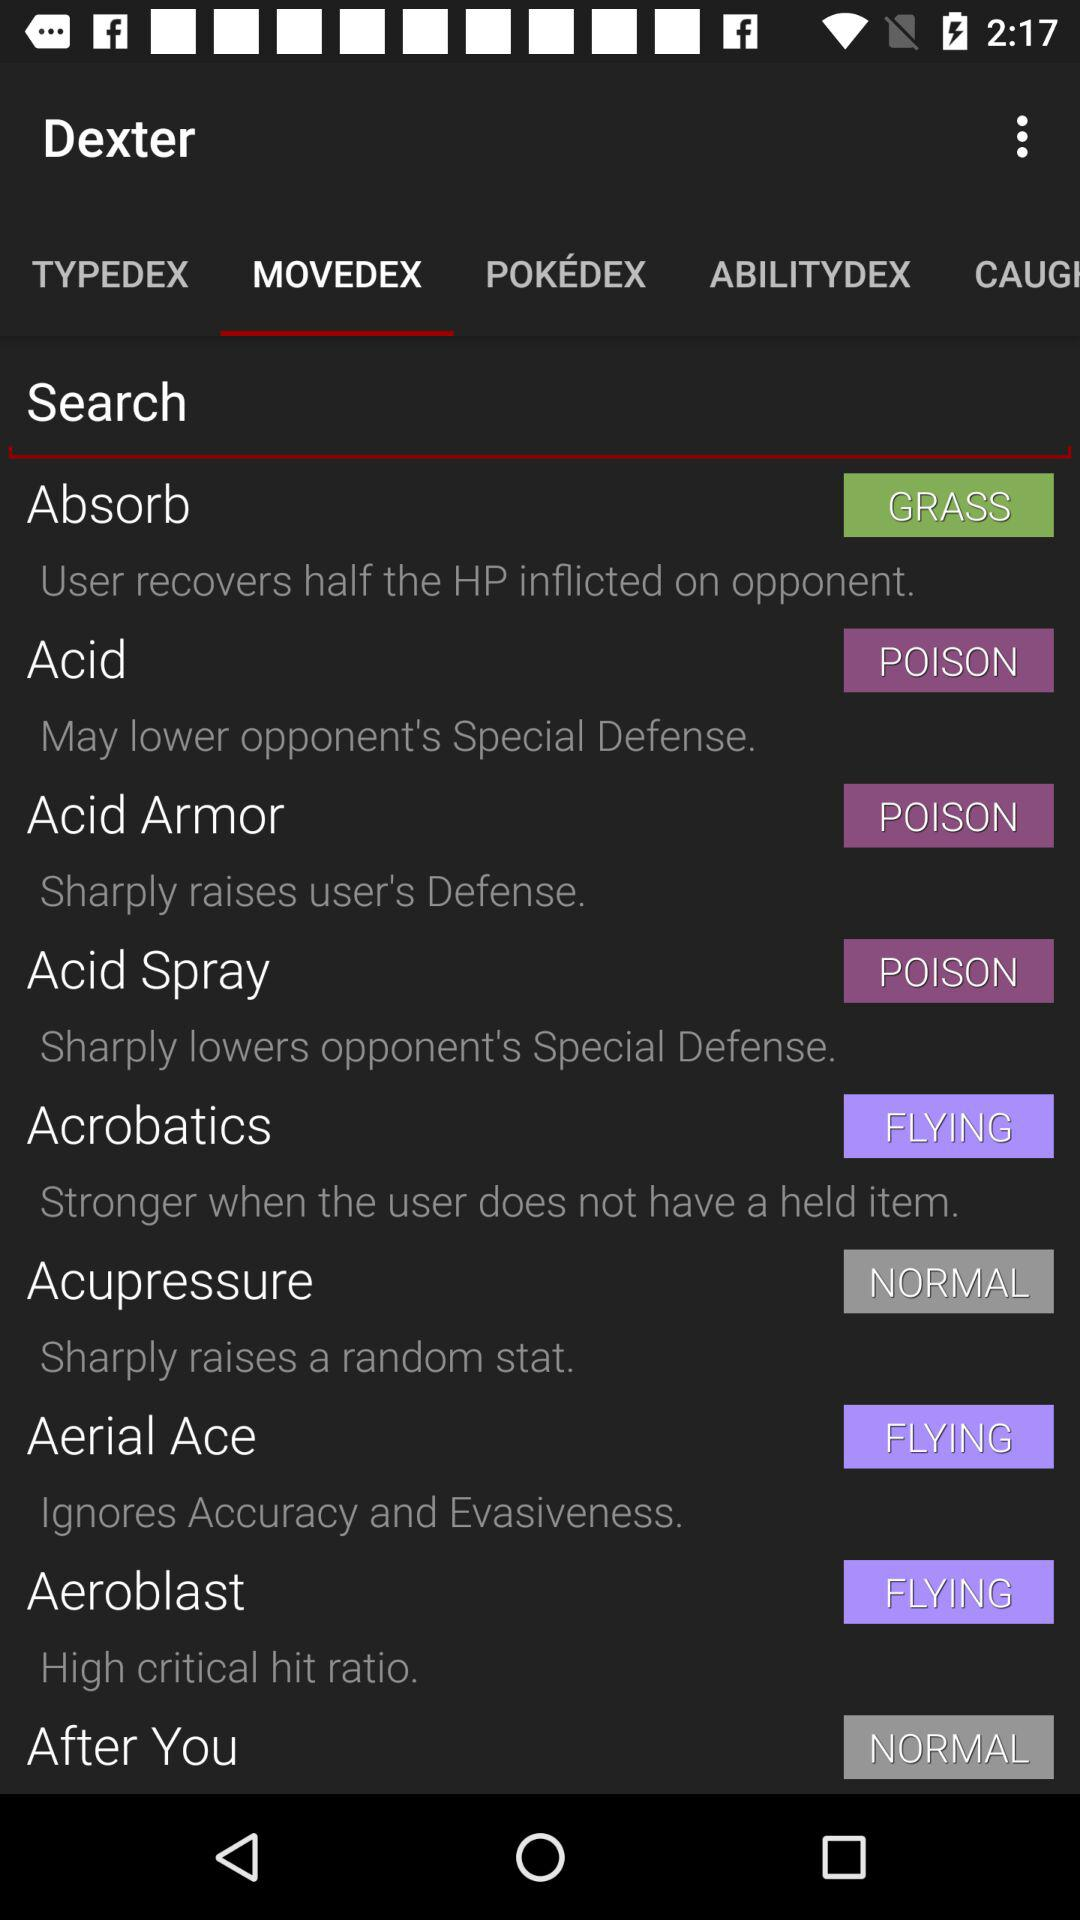What is the description of the "Acid"? The description of the "Acid" is "May lower opponent's Special Defense". 